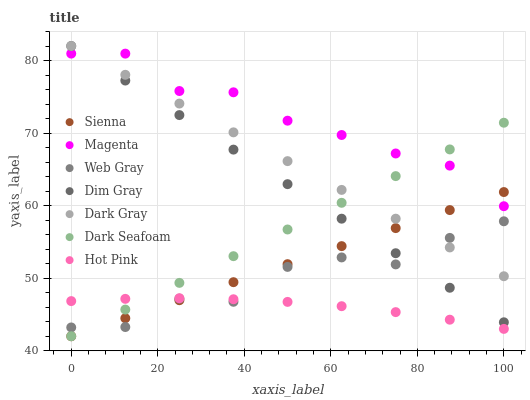Does Hot Pink have the minimum area under the curve?
Answer yes or no. Yes. Does Magenta have the maximum area under the curve?
Answer yes or no. Yes. Does Web Gray have the minimum area under the curve?
Answer yes or no. No. Does Web Gray have the maximum area under the curve?
Answer yes or no. No. Is Sienna the smoothest?
Answer yes or no. Yes. Is Web Gray the roughest?
Answer yes or no. Yes. Is Hot Pink the smoothest?
Answer yes or no. No. Is Hot Pink the roughest?
Answer yes or no. No. Does Sienna have the lowest value?
Answer yes or no. Yes. Does Web Gray have the lowest value?
Answer yes or no. No. Does Dim Gray have the highest value?
Answer yes or no. Yes. Does Web Gray have the highest value?
Answer yes or no. No. Is Hot Pink less than Magenta?
Answer yes or no. Yes. Is Dim Gray greater than Hot Pink?
Answer yes or no. Yes. Does Web Gray intersect Dark Gray?
Answer yes or no. Yes. Is Web Gray less than Dark Gray?
Answer yes or no. No. Is Web Gray greater than Dark Gray?
Answer yes or no. No. Does Hot Pink intersect Magenta?
Answer yes or no. No. 